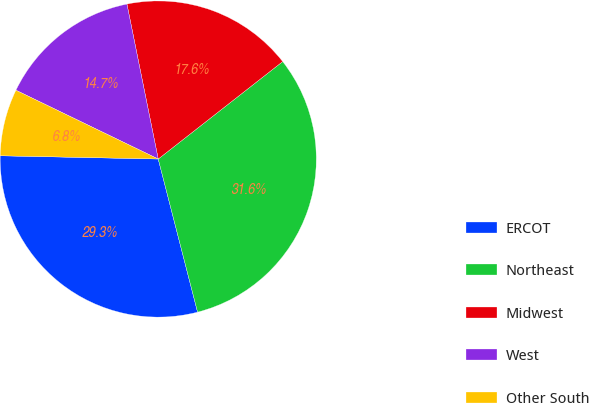<chart> <loc_0><loc_0><loc_500><loc_500><pie_chart><fcel>ERCOT<fcel>Northeast<fcel>Midwest<fcel>West<fcel>Other South<nl><fcel>29.33%<fcel>31.57%<fcel>17.6%<fcel>14.66%<fcel>6.84%<nl></chart> 